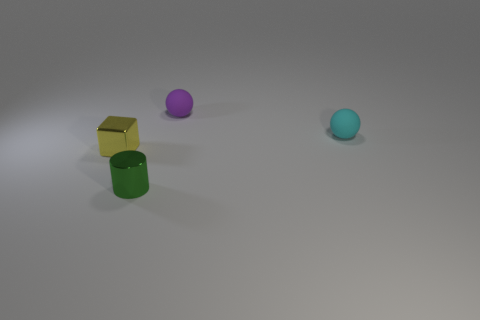What number of things are either small spheres or yellow cubes?
Keep it short and to the point. 3. The thing that is both in front of the cyan rubber object and behind the tiny shiny cylinder has what shape?
Keep it short and to the point. Cube. What number of green cubes are there?
Your answer should be compact. 0. There is a cylinder that is made of the same material as the yellow thing; what color is it?
Your answer should be very brief. Green. Are there more big yellow matte cylinders than spheres?
Give a very brief answer. No. There is a thing that is in front of the purple rubber ball and behind the yellow shiny block; how big is it?
Your answer should be compact. Small. Is the number of green metallic cylinders behind the tiny cyan rubber object the same as the number of purple rubber spheres?
Ensure brevity in your answer.  No. Is the purple rubber sphere the same size as the cylinder?
Your answer should be compact. Yes. What is the color of the thing that is both in front of the cyan rubber sphere and behind the green object?
Your response must be concise. Yellow. What material is the object that is left of the shiny thing that is on the right side of the yellow cube made of?
Offer a very short reply. Metal. 